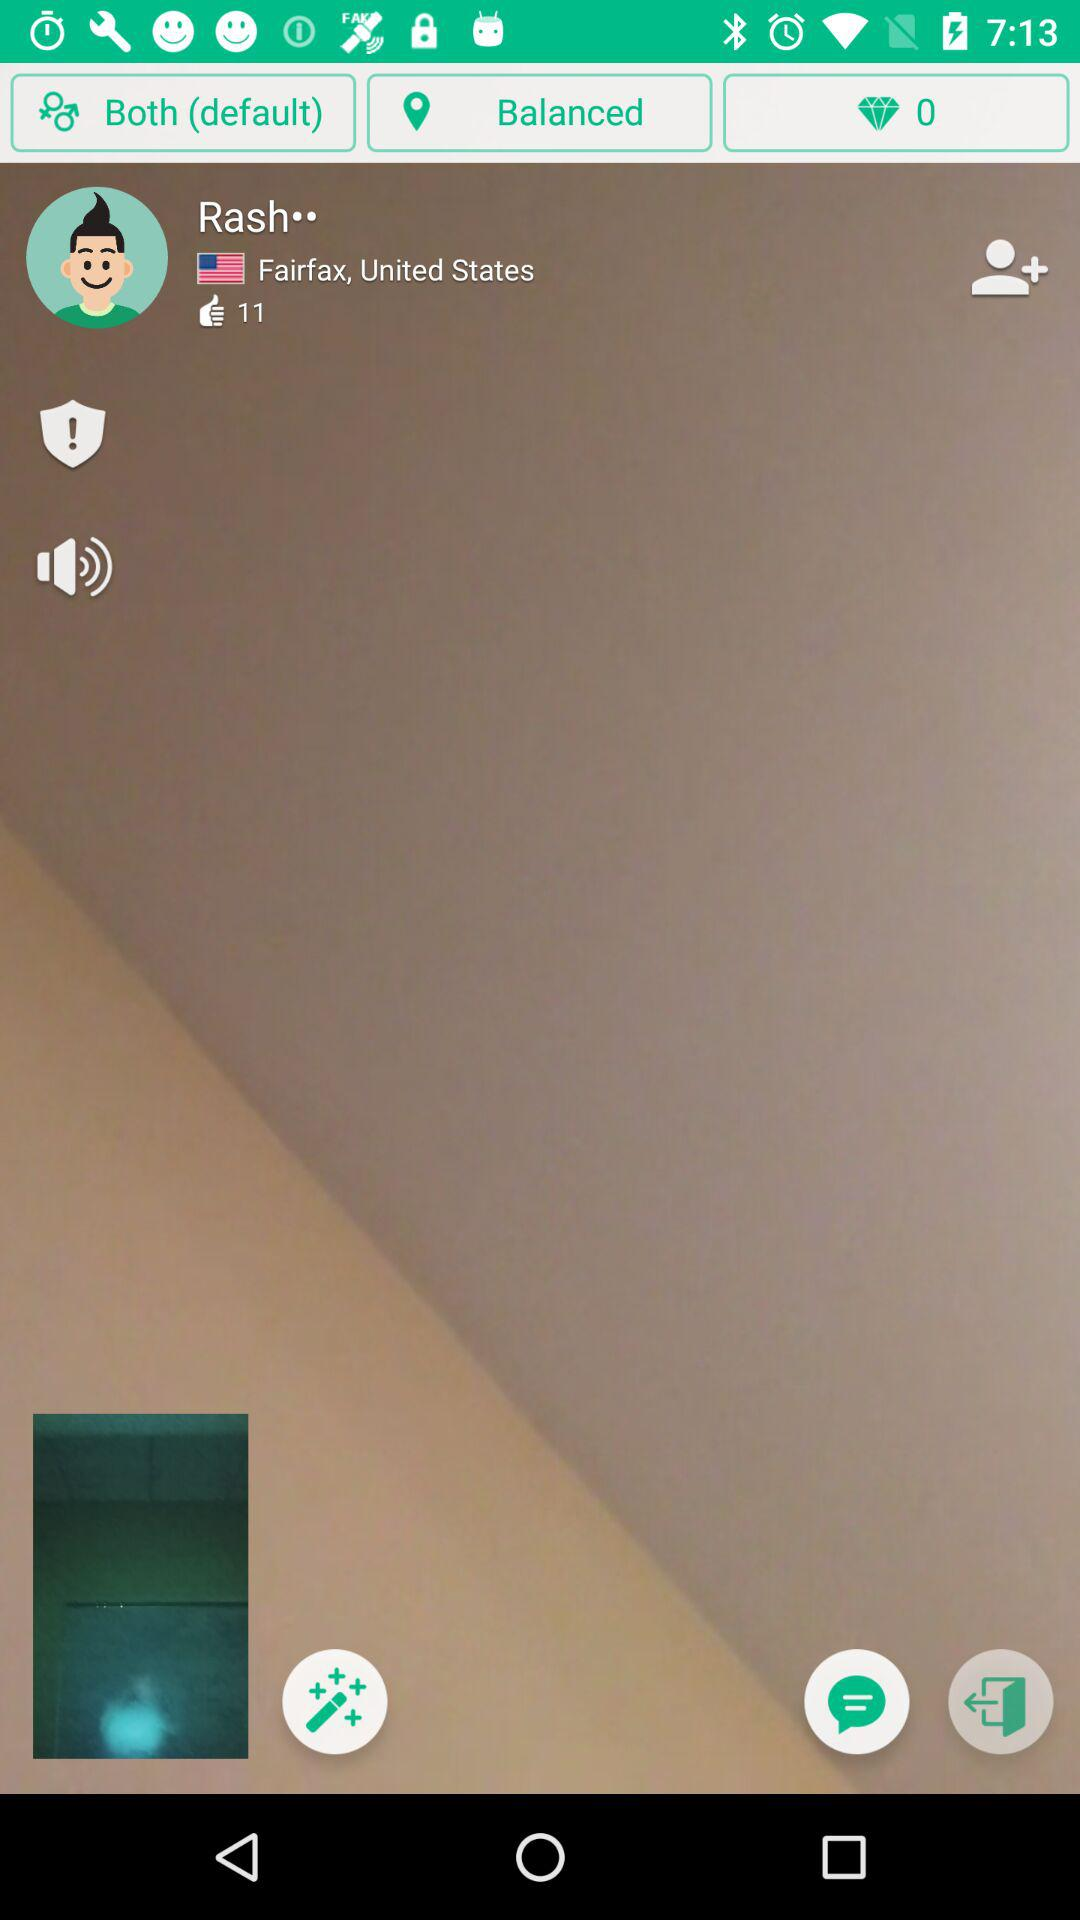How many likes did Rash get? Rash gets 11 likes. 